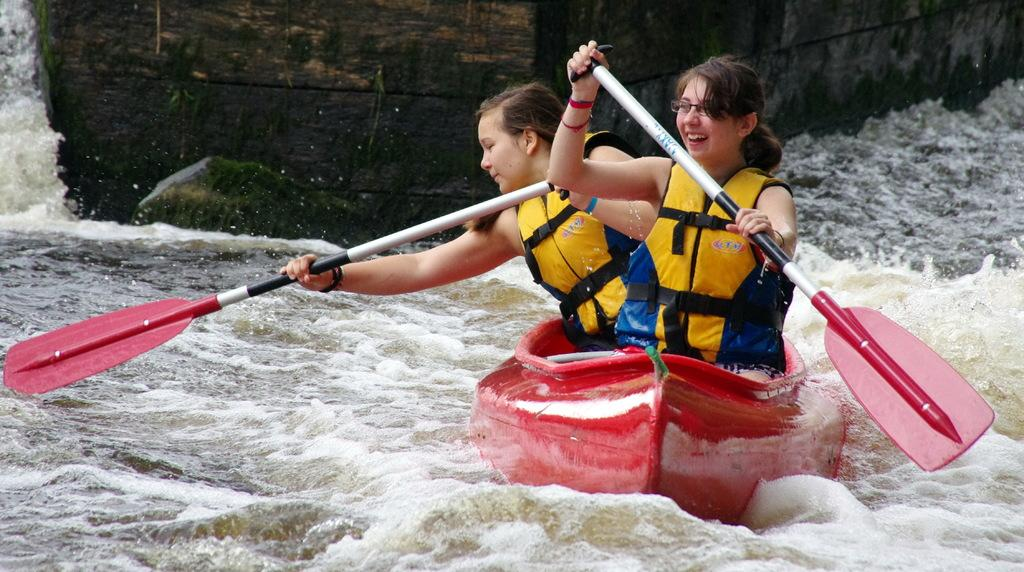How many people are in the image? There are two girls in the image. What are the girls doing in the image? The girls are sitting in a boat. What is the primary setting of the image? There is water visible in the image. What else can be seen in the image? There is a wall in the image. What type of trade is being conducted in the image? There is no indication of any trade being conducted in the image; it features two girls sitting in a boat. How does the noise level in the image compare to a typical conversation? There is no information about noise levels in the image, as it focuses on the girls sitting in a boat and the surrounding water and wall. 